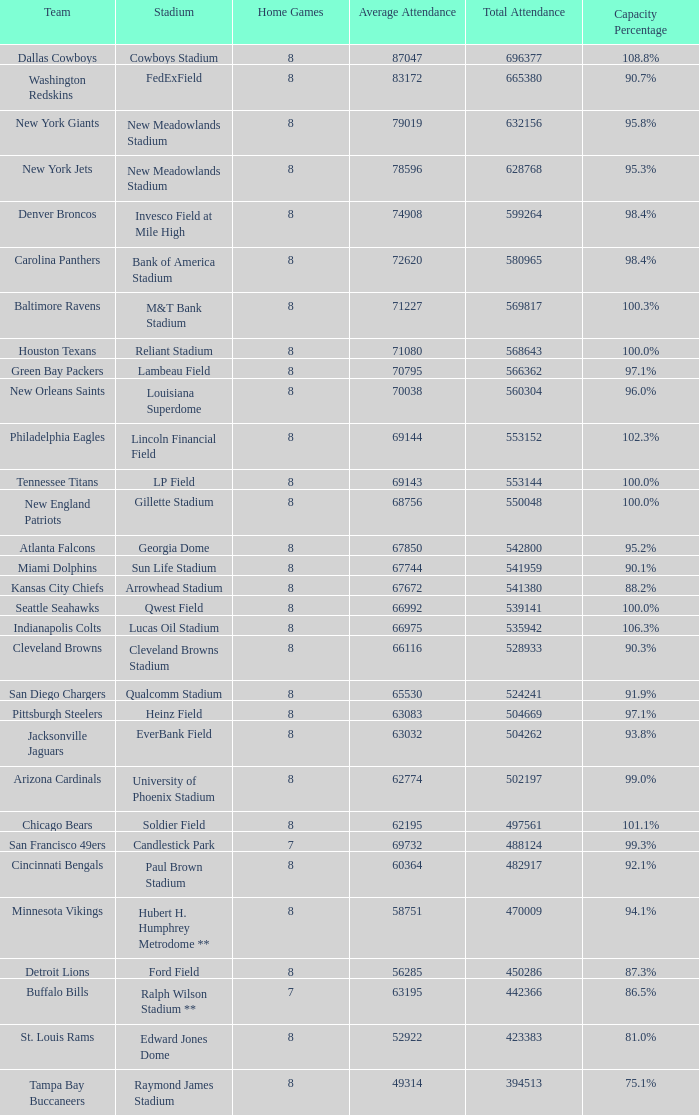How many teams had a 99.3% capacity rating? 1.0. 